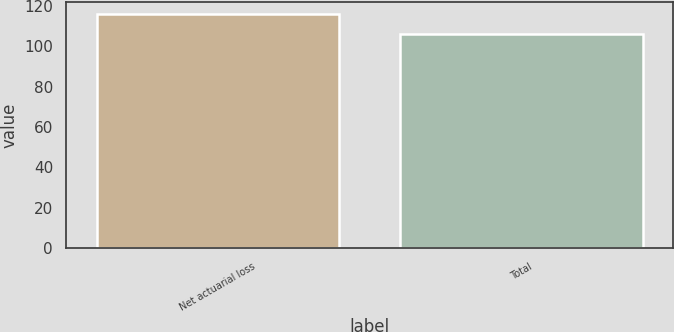Convert chart. <chart><loc_0><loc_0><loc_500><loc_500><bar_chart><fcel>Net actuarial loss<fcel>Total<nl><fcel>116<fcel>106<nl></chart> 